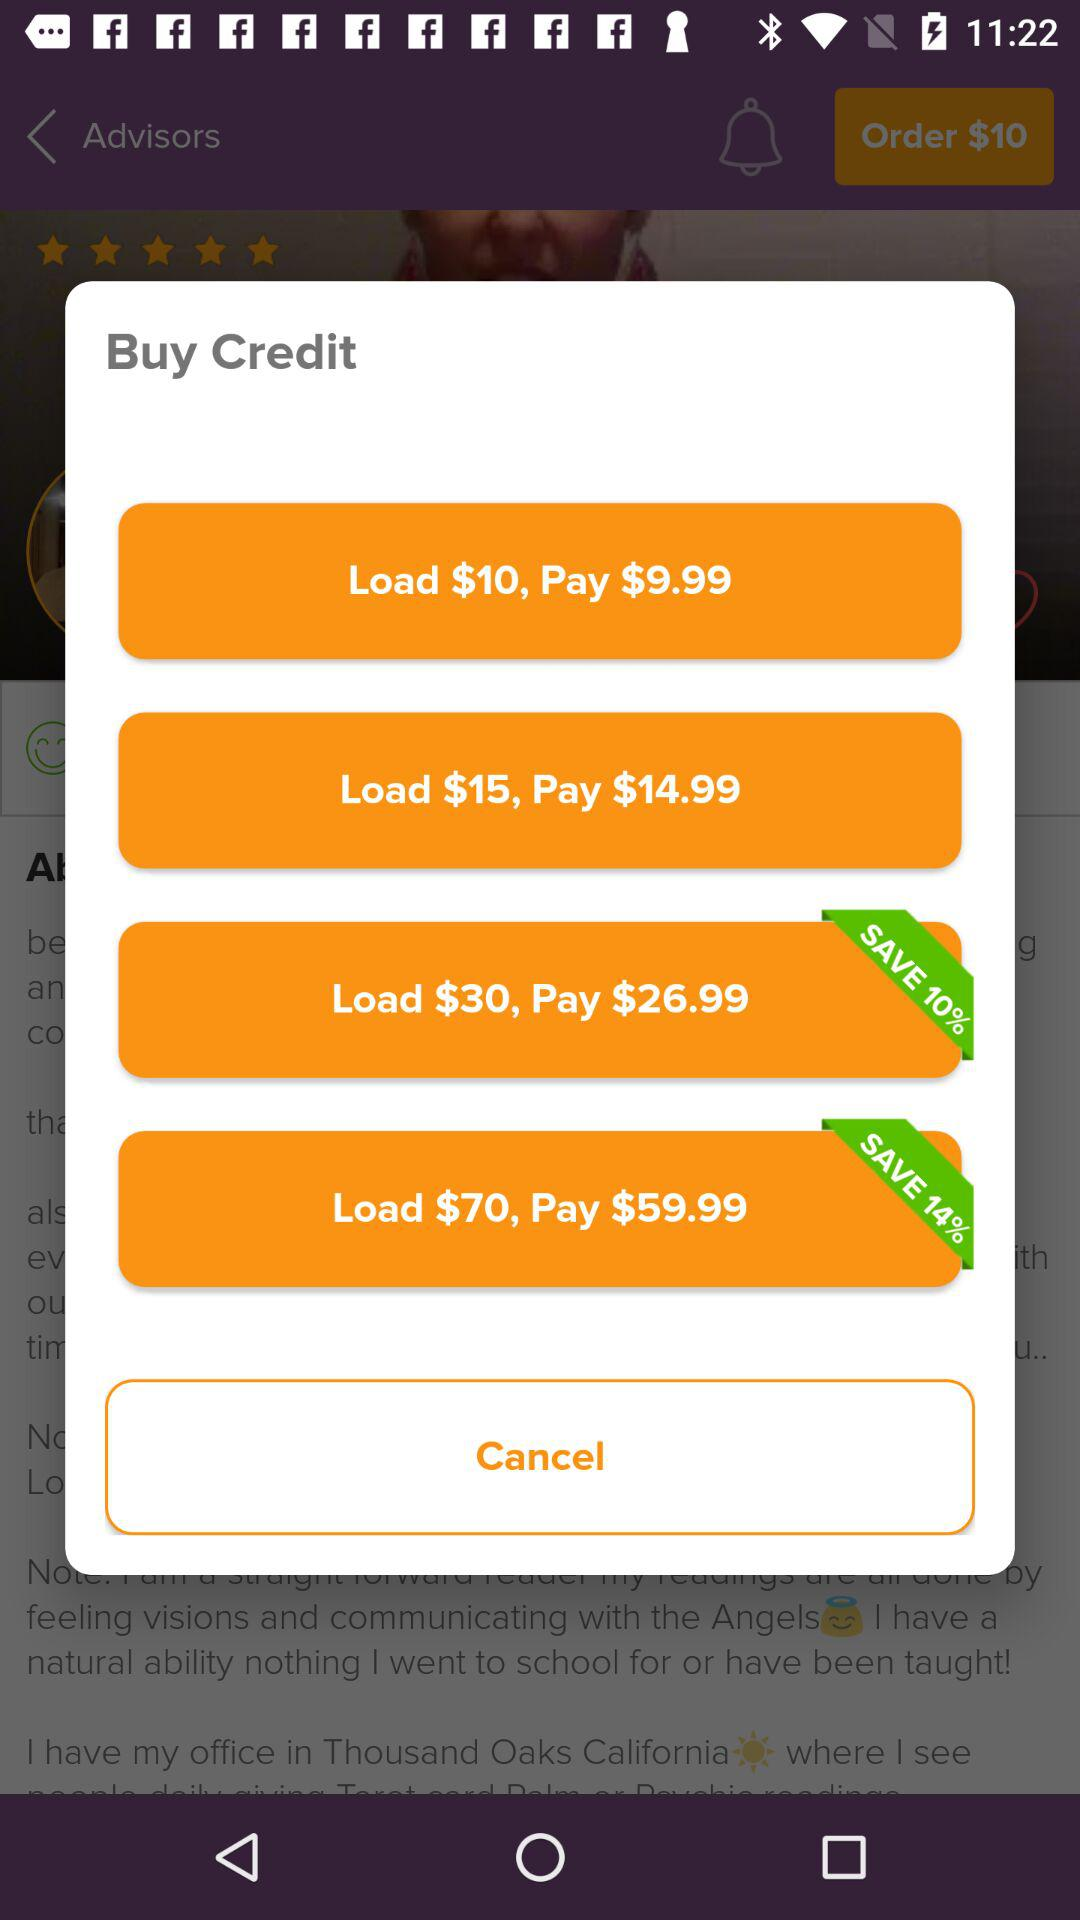What is the price for loading $10? The price for loading $10 is $9.99. 